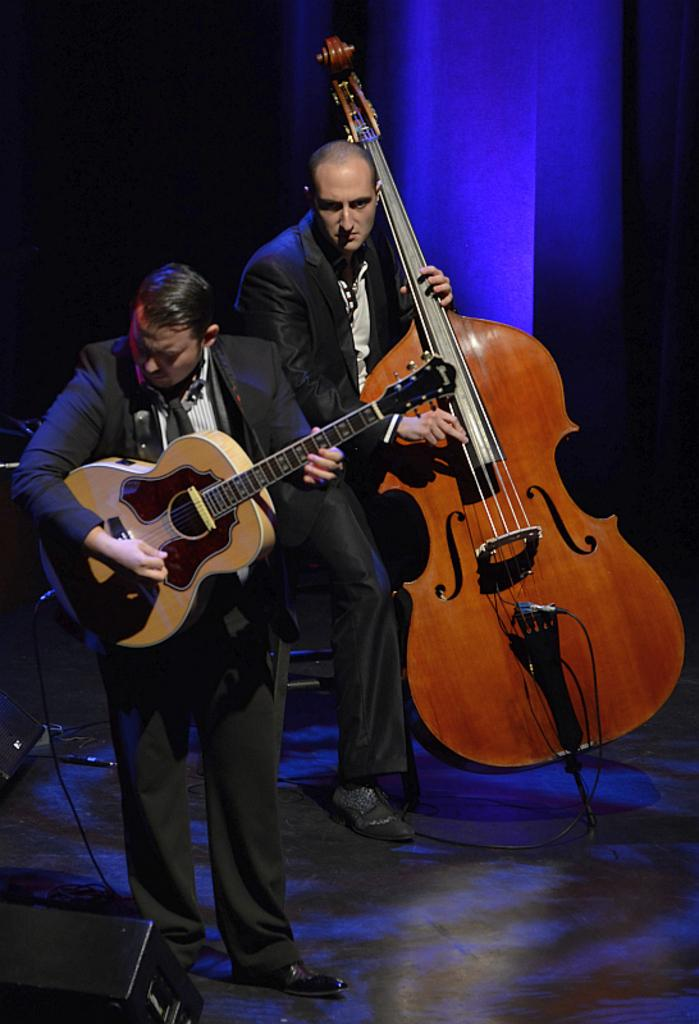How many people are in the image? There are two persons in the image. What are the people doing in the image? One person is standing and holding a guitar, while the other person is playing the violin. Is the person with the guitar playing it? Yes, the person with the guitar is playing it. What can be seen in the background of the image? There is some light visible in the background of the image. Where is the shelf located in the image? There is no shelf present in the image. What type of company is depicted in the image? There is no company depicted in the image; it features two people playing musical instruments. 